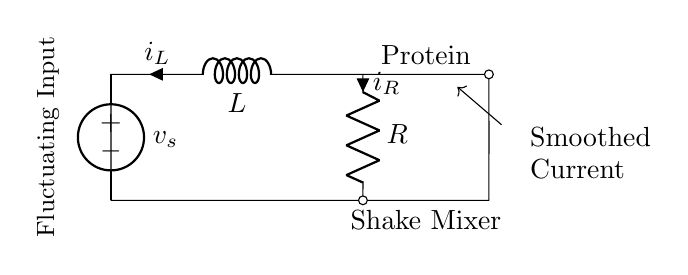What is the type of the voltage source in this circuit? The voltage source is labeled as an American voltage source in the diagram. It serves as the input power for the RL network.
Answer: American voltage source What does the inductor represent in this circuit? The inductor represents a component that stores energy in a magnetic field when current flows through it, helping to smooth out fluctuations in current.
Answer: Energy storage What is the purpose of the resistor in this RL network? The resistor limits the current flowing through the circuit and dissipates energy in the form of heat, working in conjunction with the inductor to control current changes.
Answer: Current limiting How are the inductor and resistor connected in this circuit? The inductor and resistor are connected in series, which means the same current flows through both components. This configuration affects how current changes over time.
Answer: Series connection What is the function of the circuit as indicated in the diagram? The circuit is designed to smooth the fluctuating current from the protein shake mixer, ensuring stable operation during mixing.
Answer: Smoothing current fluctuations What does the label "Fluctuating Input" indicate? The label indicates that the voltage applied to the circuit varies over time, which the RL network is designed to mitigate by providing a smoother current output.
Answer: Input variation What happens to the current when the voltage across the inductor increases? When the voltage across the inductor increases, the inductor opposes changes in current due to its stored energy, resulting in a gradual increase in current rather than an abrupt change.
Answer: Gradual increase 